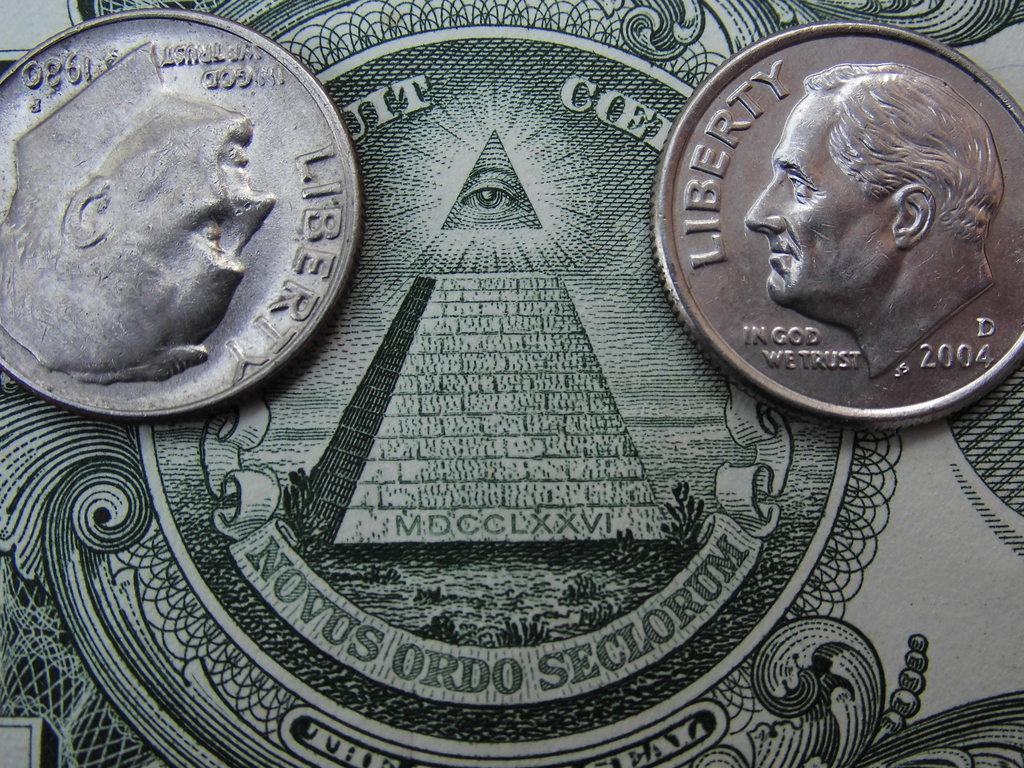<image>
Create a compact narrative representing the image presented. a dime that has the word liberty on it 